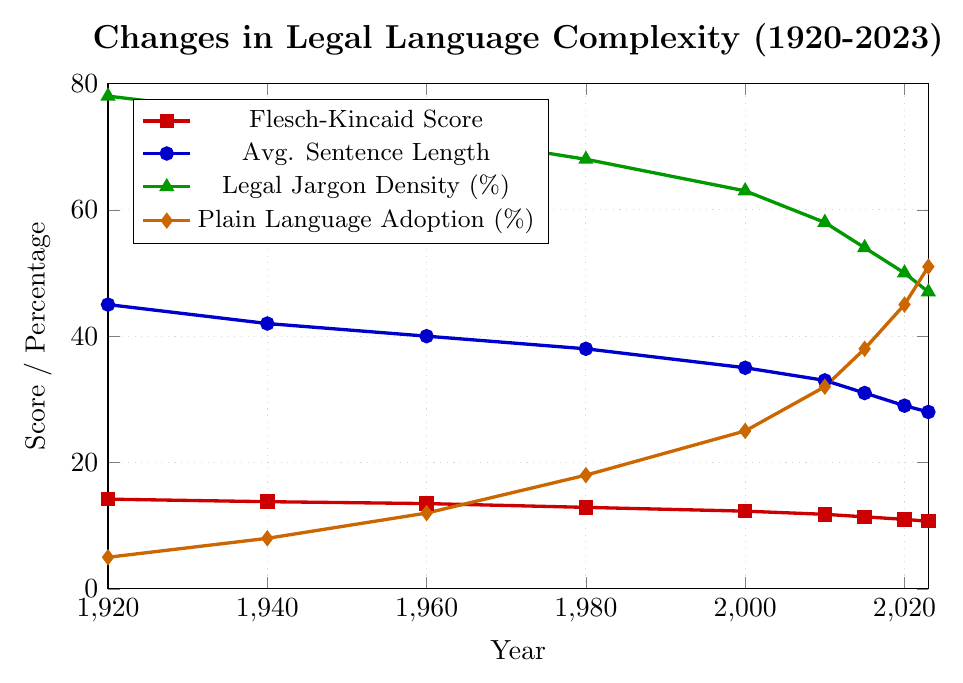What's the overall trend in the Flesch-Kincaid Score from 1920 to 2023? The Flesch-Kincaid Score shows a downward trend from 14.2 in 1920 to 10.7 in 2023. The decreasing values indicate that legal language is becoming less complex over time.
Answer: Downward trend How much did the average sentence length reduce from 1920 to 2023? To find the reduction, subtract the average sentence length in 2023 from that in 1920: 45 (in 1920) - 28 (in 2023) = 17 words. Therefore, the average sentence length decreased by 17 words.
Answer: 17 words Which year saw the highest percentage of plain language adoption? By looking at the figure, the highest percentage of plain language adoption occurred in 2023 at 51%.
Answer: 2023 Compare the legal jargon density in 1980 and 2020. Which year had a higher density and by how much? In 1980, the legal jargon density was 68%, and in 2020, it was 50%. 1980 had a higher density. The difference is 68% - 50% = 18%.
Answer: 1980, by 18% What is the difference in the Flesch-Kincaid Score between 1940 and 2000? The Flesch-Kincaid Score in 1940 was 13.8 and in 2000 it was 12.3. The difference is 13.8 - 12.3 = 1.5.
Answer: 1.5 How did the percentage of plain language adoption change from 1960 to 2010? In 1960, plain language adoption was at 12%, and in 2010, it was at 32%. The change is 32% - 12% = 20%.
Answer: Increased by 20% During which period did the average sentence length show the most significant decrease? By observing the chart, the largest drop in average sentence length is between 1920 and 1940, where it went from 45 to 42 words, a decrease of 3 words.
Answer: 1920-1940 What is the trend in legal jargon density from 1920 to 2023? The legal jargon density shows a decreasing trend, dropping from 78% in 1920 to 47% in 2023, indicating a reduction in the use of complicated legal terms.
Answer: Downward trend By how much did the Flesch-Kincaid Score decrease from 2015 to 2023? The score in 2015 was 11.4 and in 2023 it was 10.7. The decrease is 11.4 - 10.7 = 0.7.
Answer: 0.7 Between 1920 and 2023, how much did the percentage of plain language adoption increase? Plain language adoption increased from 5% in 1920 to 51% in 2023. The increase is 51% - 5% = 46%.
Answer: 46% 